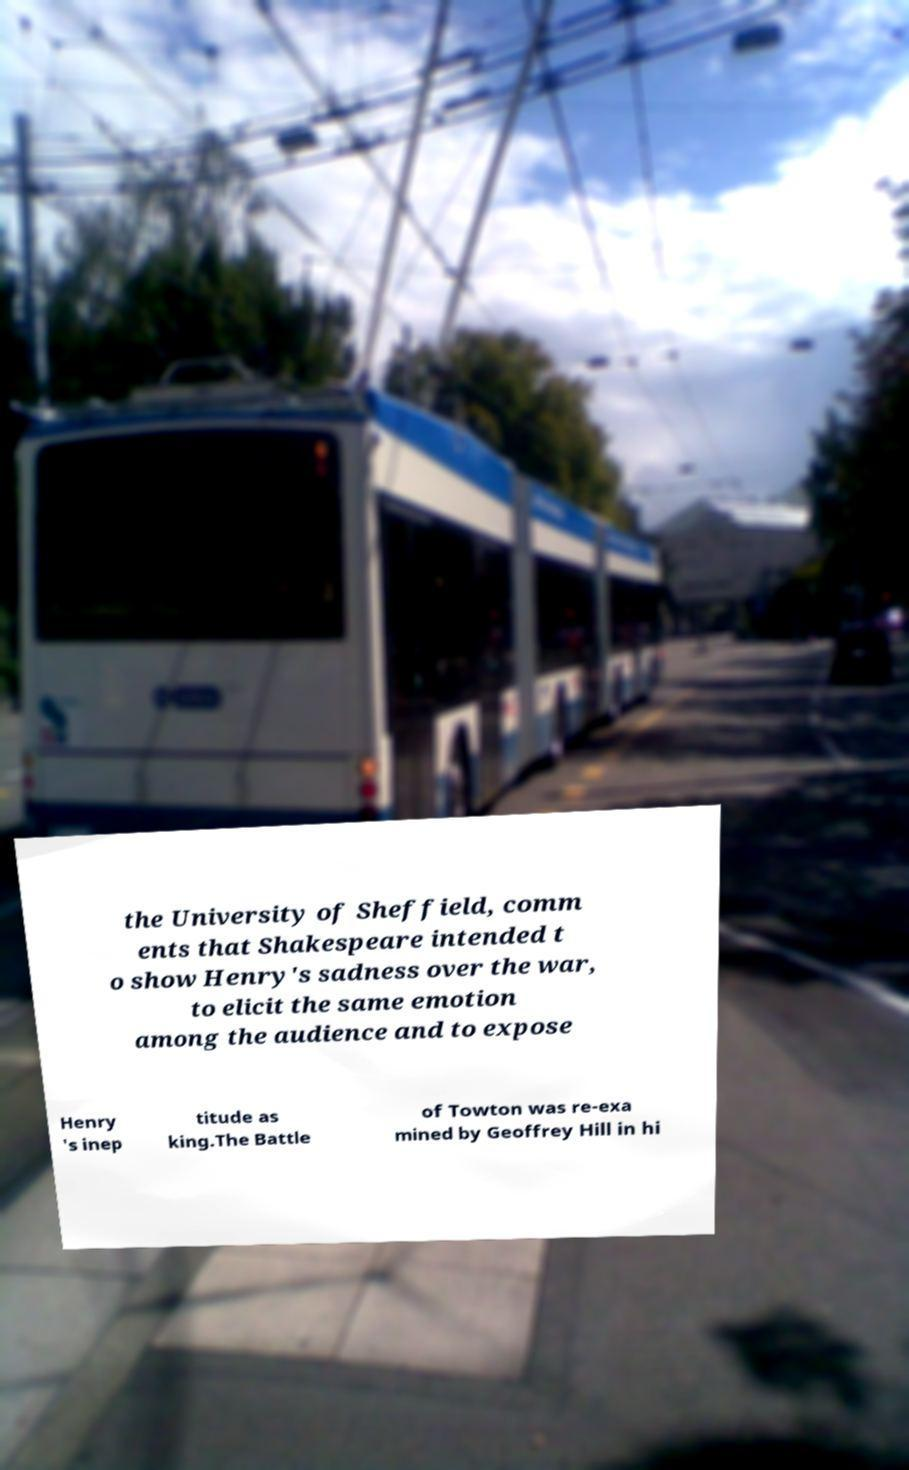Could you assist in decoding the text presented in this image and type it out clearly? the University of Sheffield, comm ents that Shakespeare intended t o show Henry's sadness over the war, to elicit the same emotion among the audience and to expose Henry 's inep titude as king.The Battle of Towton was re-exa mined by Geoffrey Hill in hi 